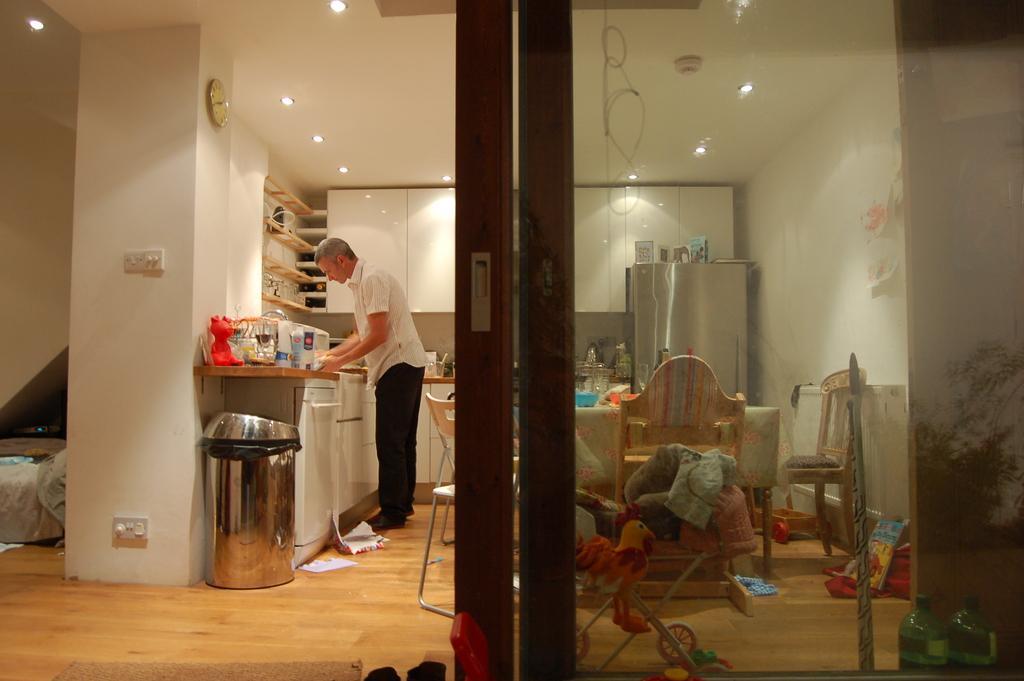Could you give a brief overview of what you see in this image? In this image we can see a person standing near a table containing some jars, glasses and bottles. We can also see a dustbin, switchboard, clock, roof, ceiling lights, glass door, dining table with chairs and a refrigerator. 